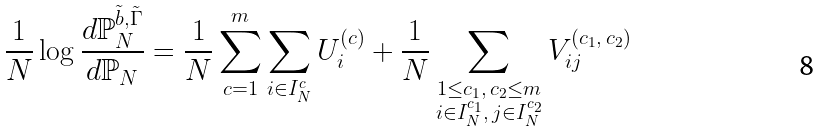Convert formula to latex. <formula><loc_0><loc_0><loc_500><loc_500>\frac { 1 } { N } \log \frac { d \mathbb { P } _ { N } ^ { \tilde { b } , \tilde { \Gamma } } } { d \mathbb { P } _ { N } } = \frac { 1 } { N } \sum _ { c = 1 } ^ { m } \sum _ { i \in I _ { N } ^ { c } } U _ { i } ^ { ( c ) } + \frac { 1 } { N } \sum _ { \substack { \substack { 1 \leq c _ { 1 } , \, c _ { 2 } \leq m \\ i \in I _ { N } ^ { c _ { 1 } } , \, j \in I _ { N } ^ { c _ { 2 } } } } } V _ { i j } ^ { ( c _ { 1 } , \, c _ { 2 } ) }</formula> 